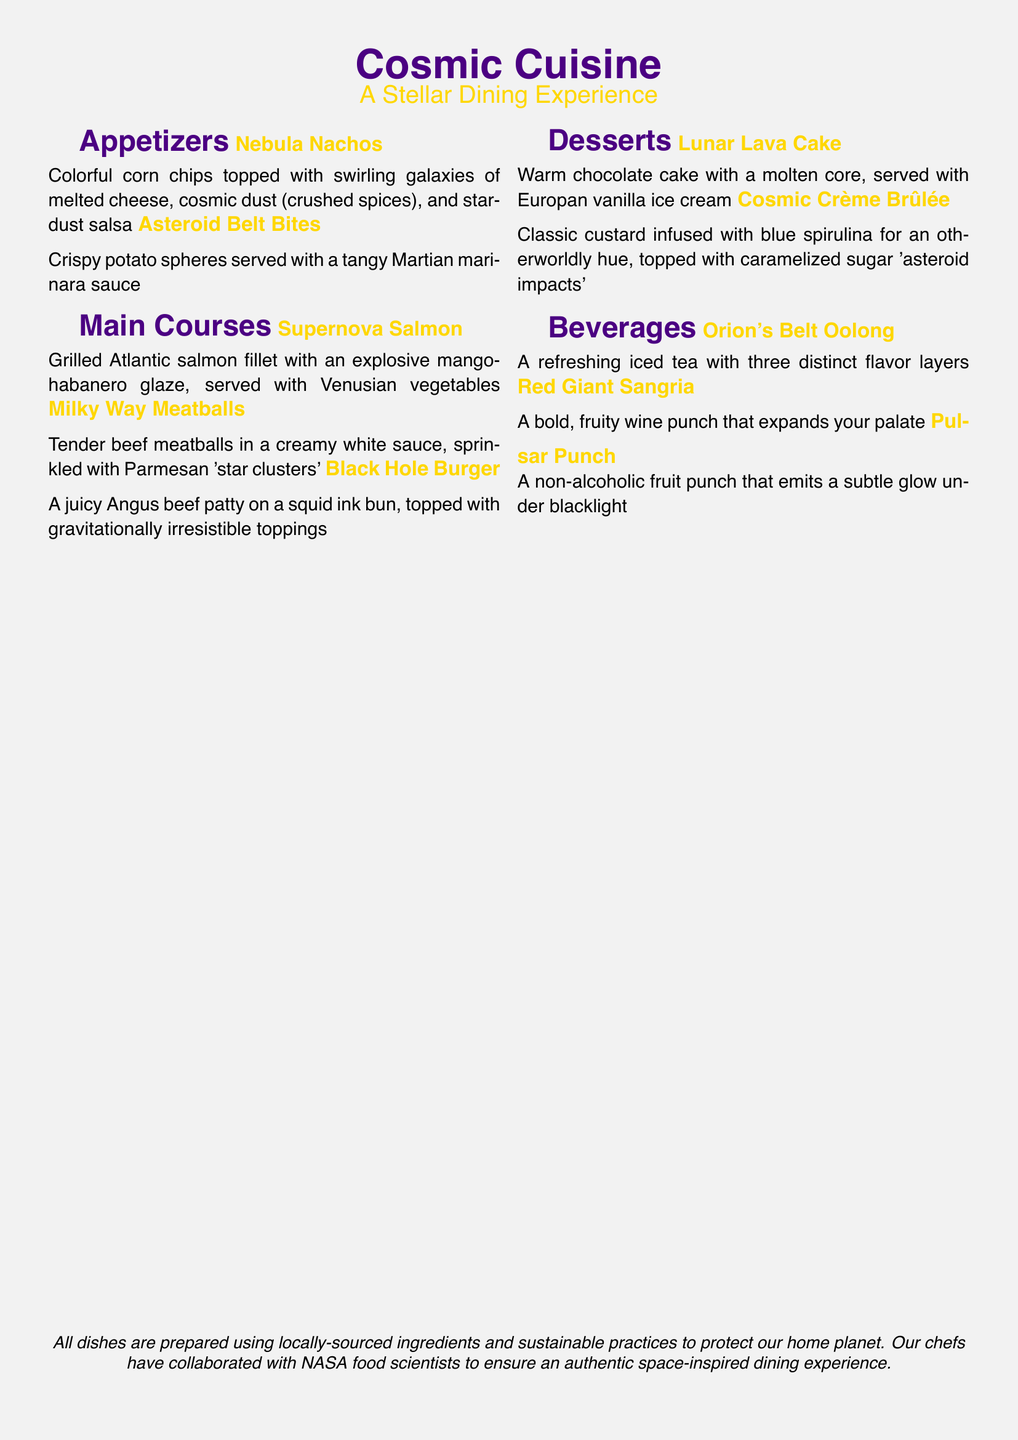What is the name of the appetizer that features corn chips? The name of the appetizer is "Nebula Nachos," which is detailed in the appetizers section of the menu.
Answer: Nebula Nachos How many main courses are listed in the menu? The main courses section lists three dishes, which can be counted directly from the menu.
Answer: Three What unique ingredient is used in the Black Hole Burger? The unique ingredient in the Black Hole Burger is a "squid ink bun," which distinguishes it from typical burgers.
Answer: Squid ink bun Which dessert is served with vanilla ice cream? The dessert served with vanilla ice cream is "Lunar Lava Cake," mentioned in the desserts section.
Answer: Lunar Lava Cake What beverage emits a subtle glow under blacklight? The beverage that emits a subtle glow under blacklight is "Pulsar Punch," as described in the beverages section.
Answer: Pulsar Punch What color is used for the section titles in the menu? The section titles are colored "spacepurple," providing a cosmic theme to the menu's appearance.
Answer: Spacepurple What type of fish is featured in the main course "Supernova Salmon"? The type of fish in "Supernova Salmon" is "Atlantic salmon," explicitly stated in the main courses section of the menu.
Answer: Atlantic salmon What ingredient is used to color the Cosmic Crème Brûlée? The ingredient used to color the Cosmic Crème Brûlée is "blue spirulina," which gives it its distinct hue.
Answer: Blue spirulina 